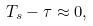<formula> <loc_0><loc_0><loc_500><loc_500>T _ { s } - \tau \approx 0 ,</formula> 